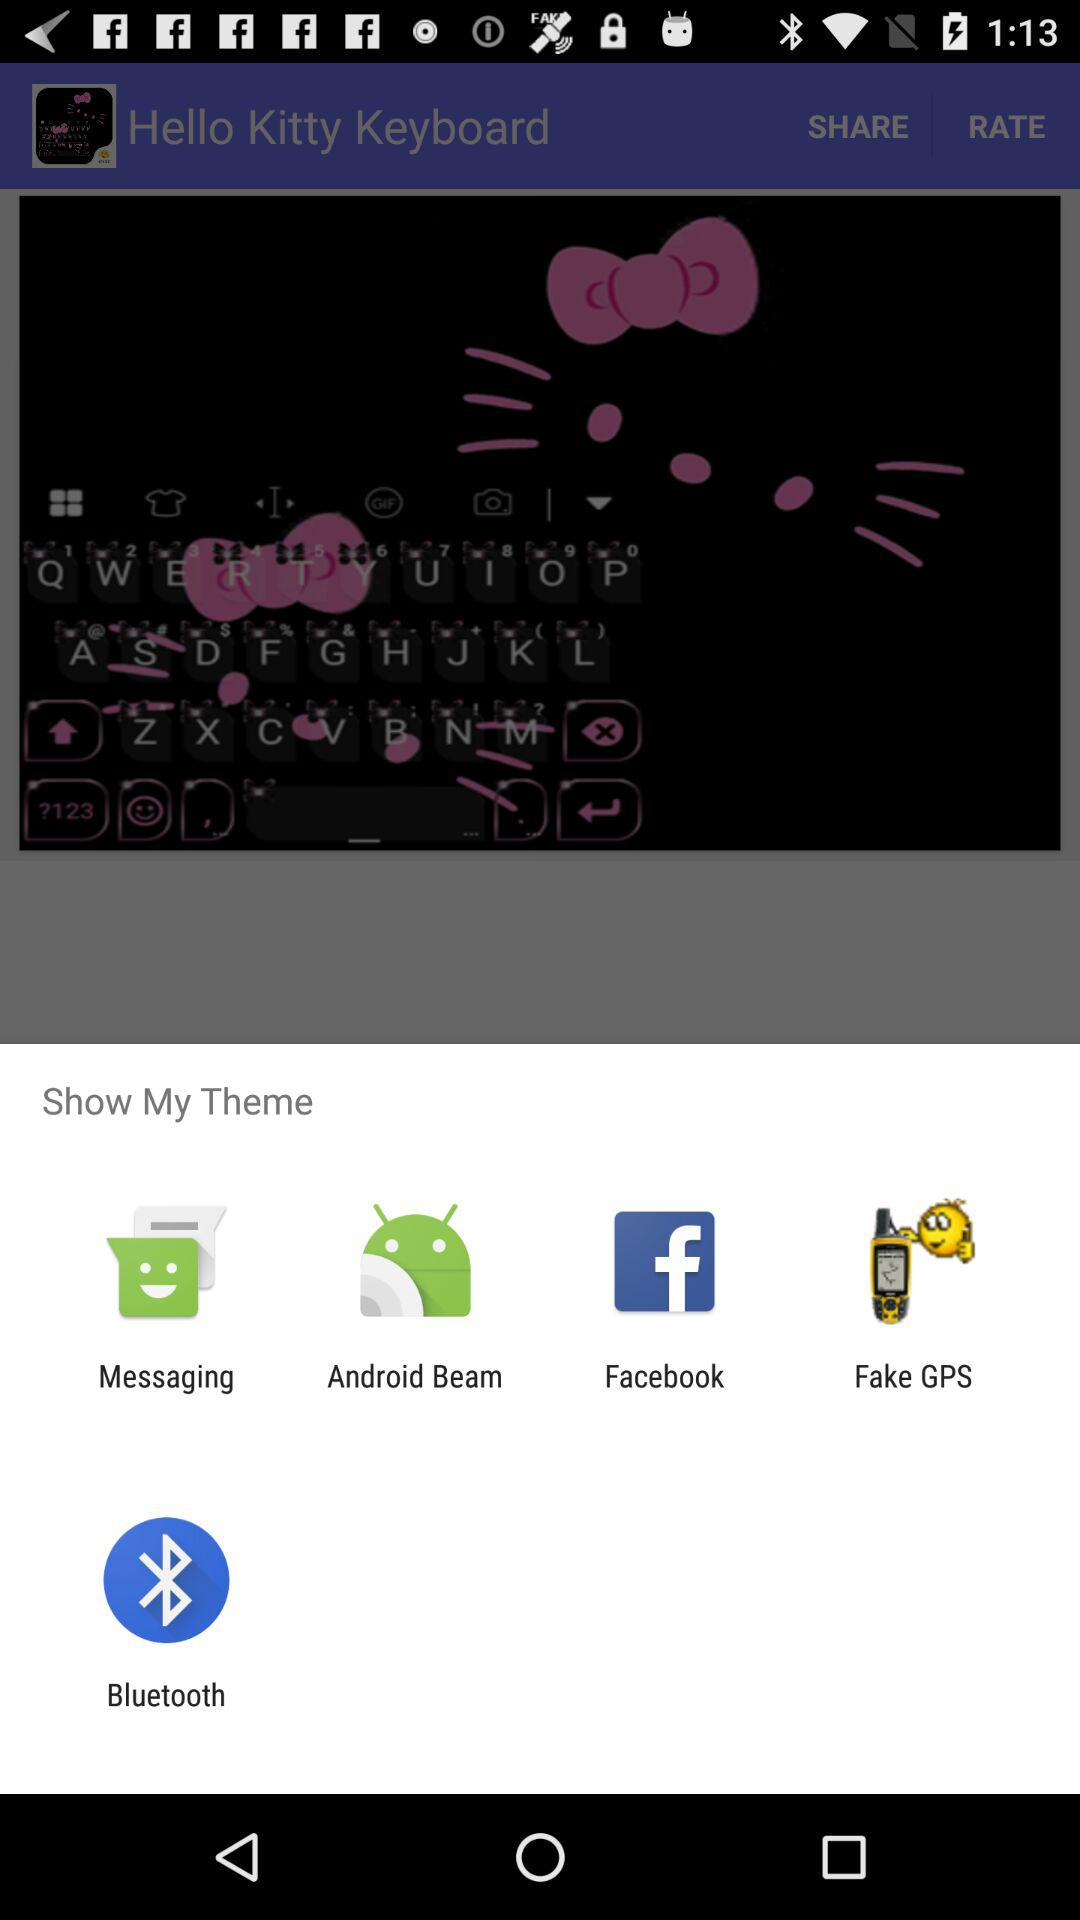Which apps can be used to show my theme? The apps that can be used are "Messaging", "Android Beam", "Facebook", "Fake GPS" and "Bluetooth". 